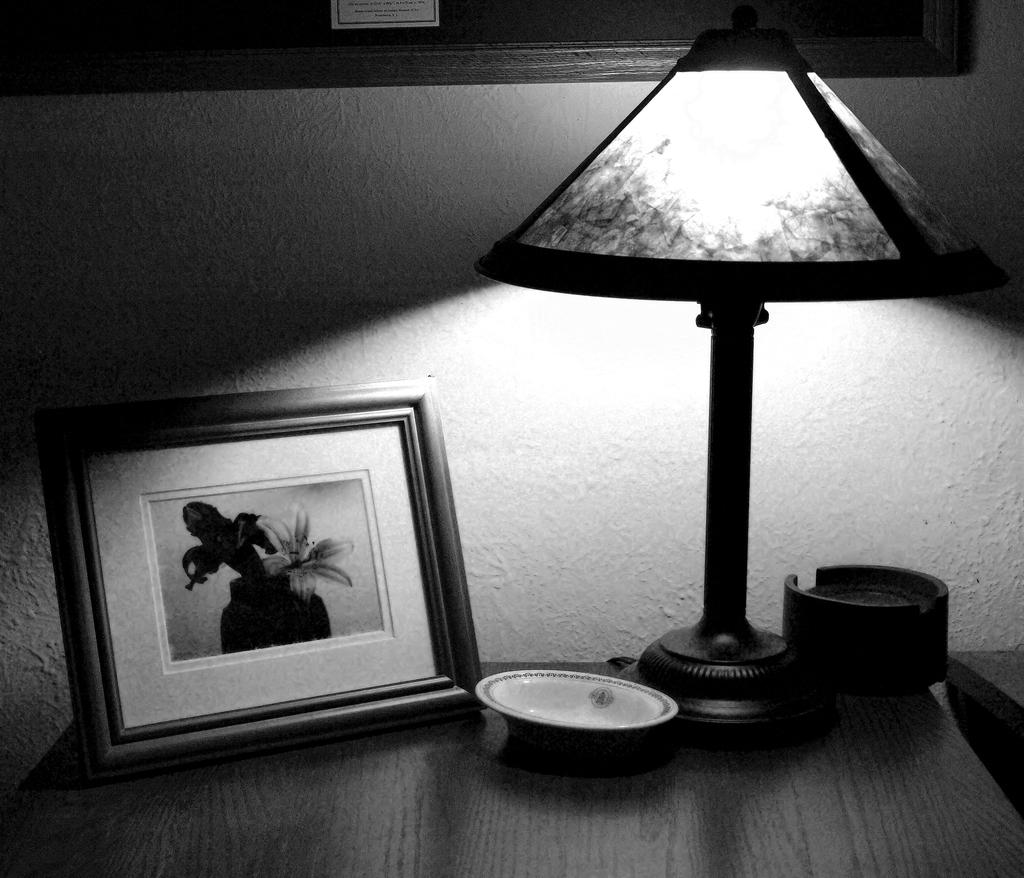What piece of furniture is present in the image? There is a table in the image. What objects are on the table? There is a photo frame and a lamp on the table. Where is the table located in relation to the wall? The table is beside a wall. What color is the wall in the image? The wall is painted white. How much anger is displayed by the wall in the image? The wall in the image does not display any emotions, including anger, as it is an inanimate object. 